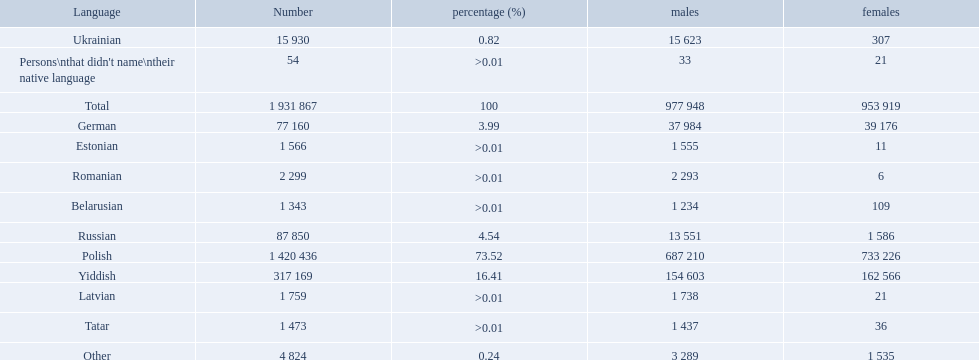What are the languages of the warsaw governorate? Polish, Yiddish, Russian, German, Ukrainian, Romanian, Latvian, Estonian, Tatar, Belarusian, Other. What is the percentage of polish? 73.52. What is the next highest amount? 16.41. What is the language with this amount? Yiddish. What are all of the languages used in the warsaw governorate? Polish, Yiddish, Russian, German, Ukrainian, Romanian, Latvian, Estonian, Tatar, Belarusian, Other, Persons\nthat didn't name\ntheir native language. Which language was comprised of the least number of female speakers? Romanian. 